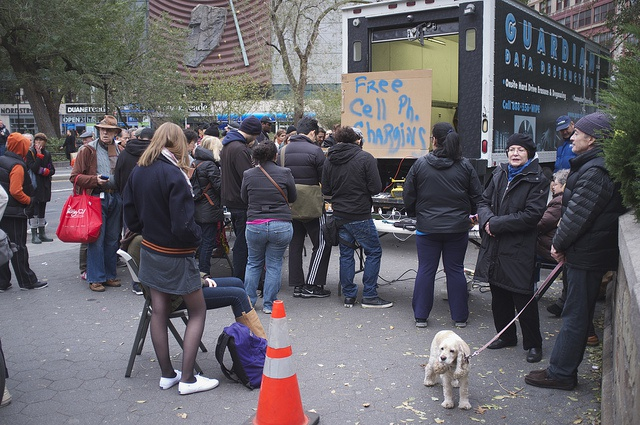Describe the objects in this image and their specific colors. I can see truck in black, gray, darkgray, and tan tones, people in black, gray, and darkgray tones, people in black and gray tones, people in black, gray, and darkgray tones, and people in black and gray tones in this image. 